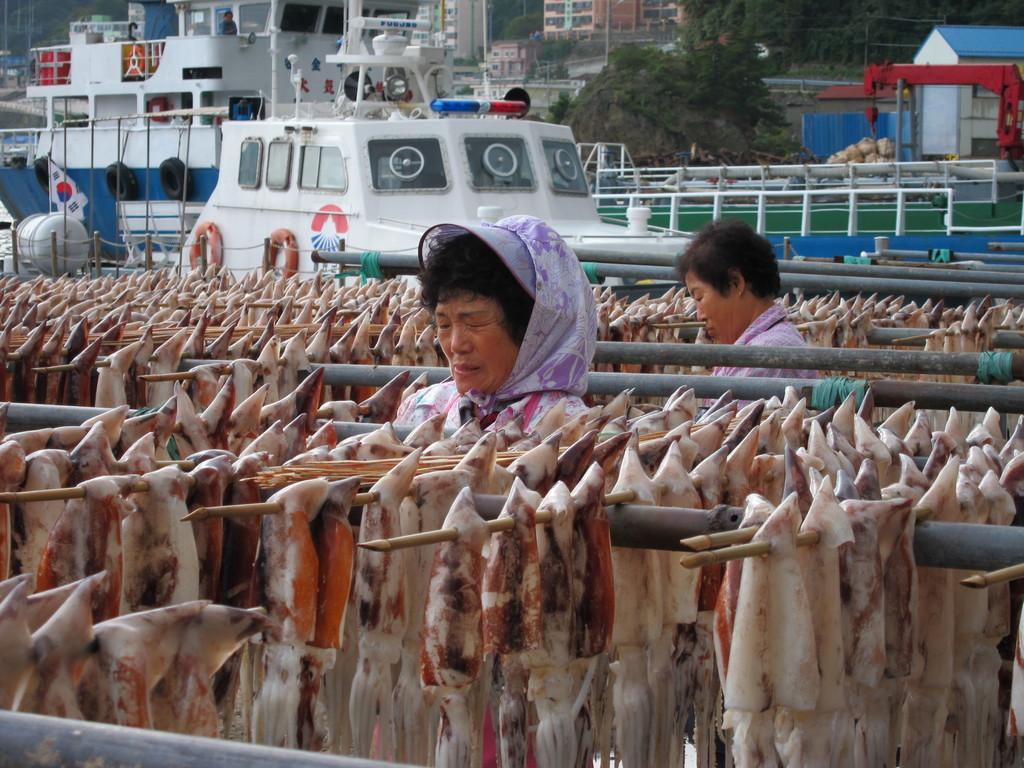What type of food is on sticks in the image? There is meat on sticks in the image. How many women are present in the image? There are two women in the image. What can be seen in the middle of the image? There are boats in the middle of the image. What is visible in the background of the image? There are buildings and trees in the background of the image. What type of silk is being used to copy the boats in the image? There is no silk or copying activity present in the image. What is the interest rate for the meat on sticks in the image? There is no mention of interest rates in the image, as it features meat on sticks and other elements. 